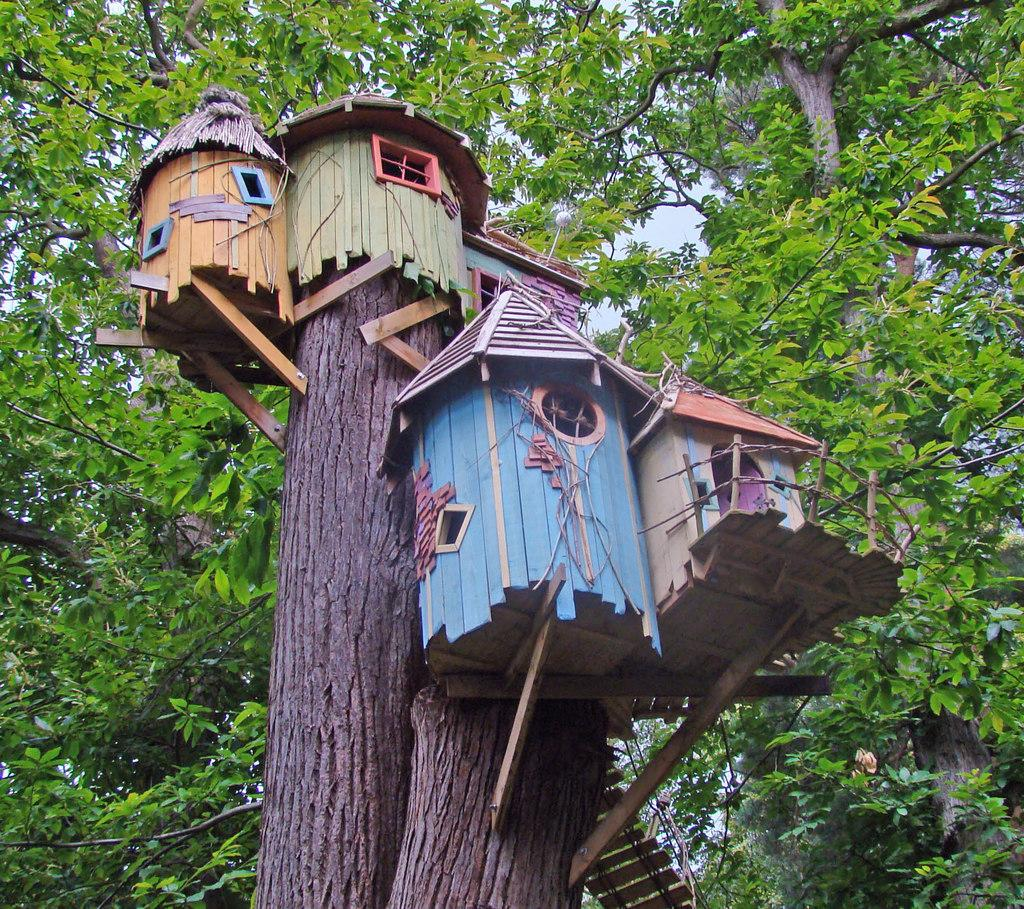What type of objects can be seen on the tree trunks in the image? There are bird houses on the tree trunks in the image. What colors are the bird houses? The bird houses have different colors: green, orange, and blue. What can be seen in the background of the image? The background of the image includes trees. How many children are playing with the fireman in the image? There are no children or firemen present in the image; it features bird houses on tree trunks. What role does the father play in the image? There is no father present in the image; it features bird houses on tree trunks. 